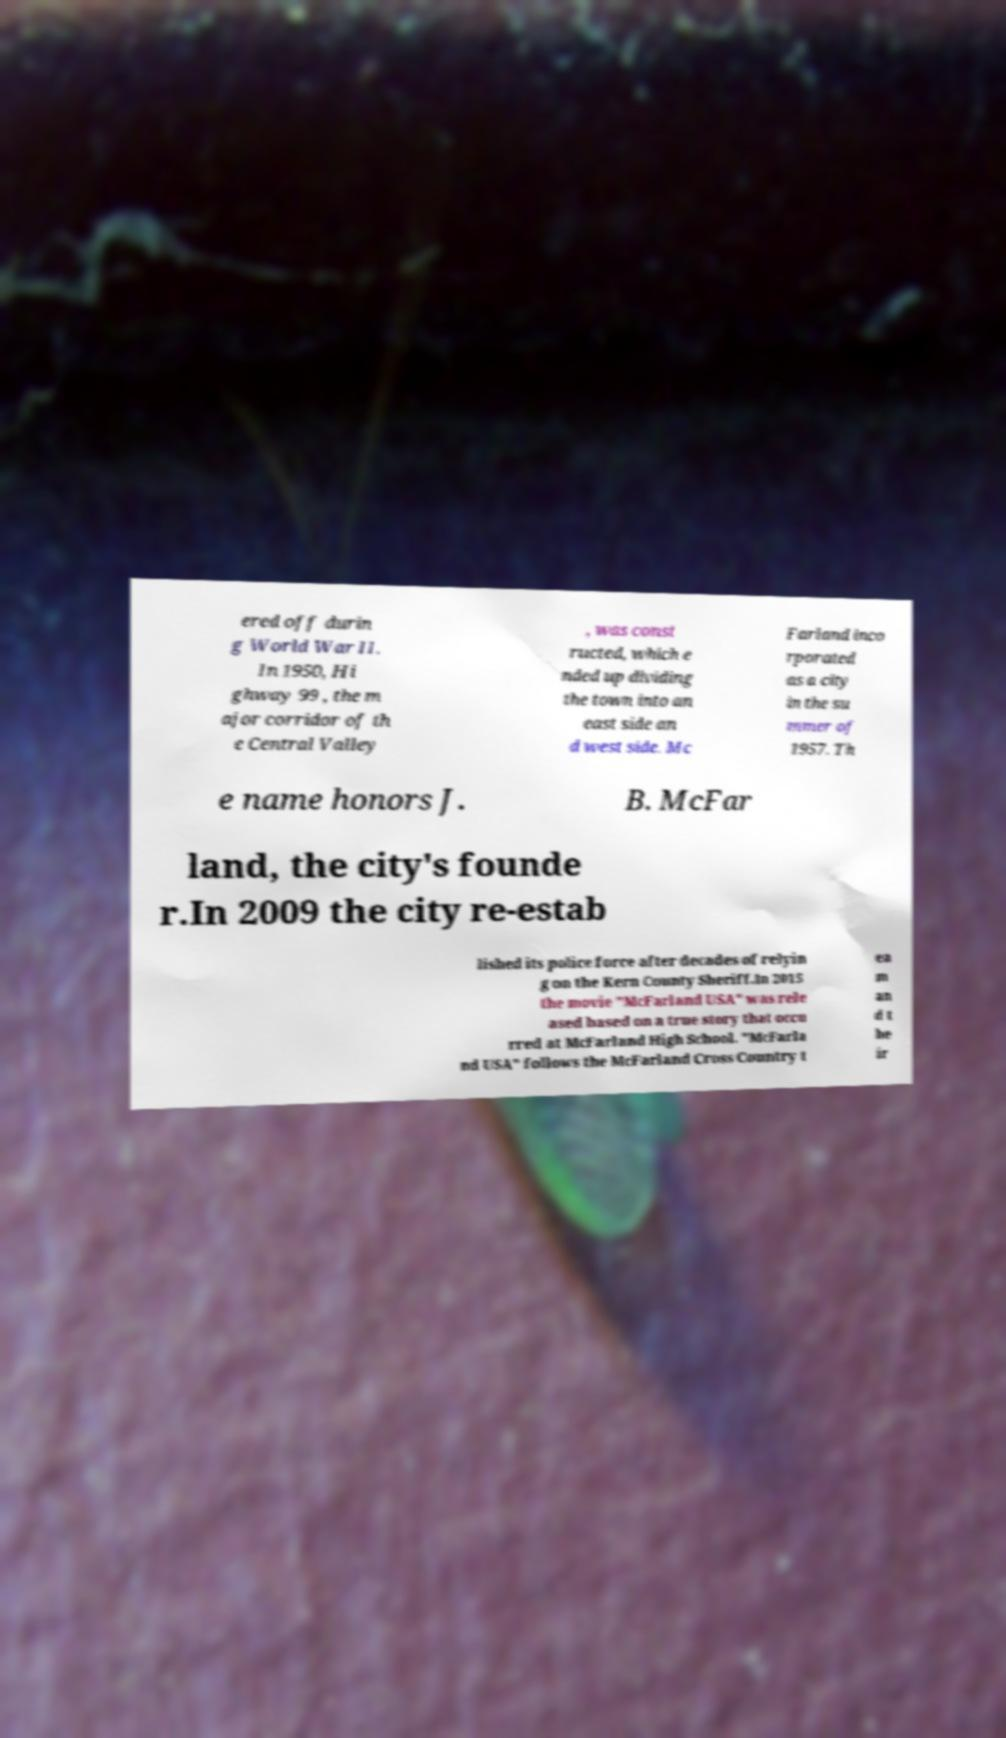I need the written content from this picture converted into text. Can you do that? ered off durin g World War II. In 1950, Hi ghway 99 , the m ajor corridor of th e Central Valley , was const ructed, which e nded up dividing the town into an east side an d west side. Mc Farland inco rporated as a city in the su mmer of 1957. Th e name honors J. B. McFar land, the city's founde r.In 2009 the city re-estab lished its police force after decades of relyin g on the Kern County Sheriff.In 2015 the movie "McFarland USA" was rele ased based on a true story that occu rred at McFarland High School. "McFarla nd USA" follows the McFarland Cross Country t ea m an d t he ir 